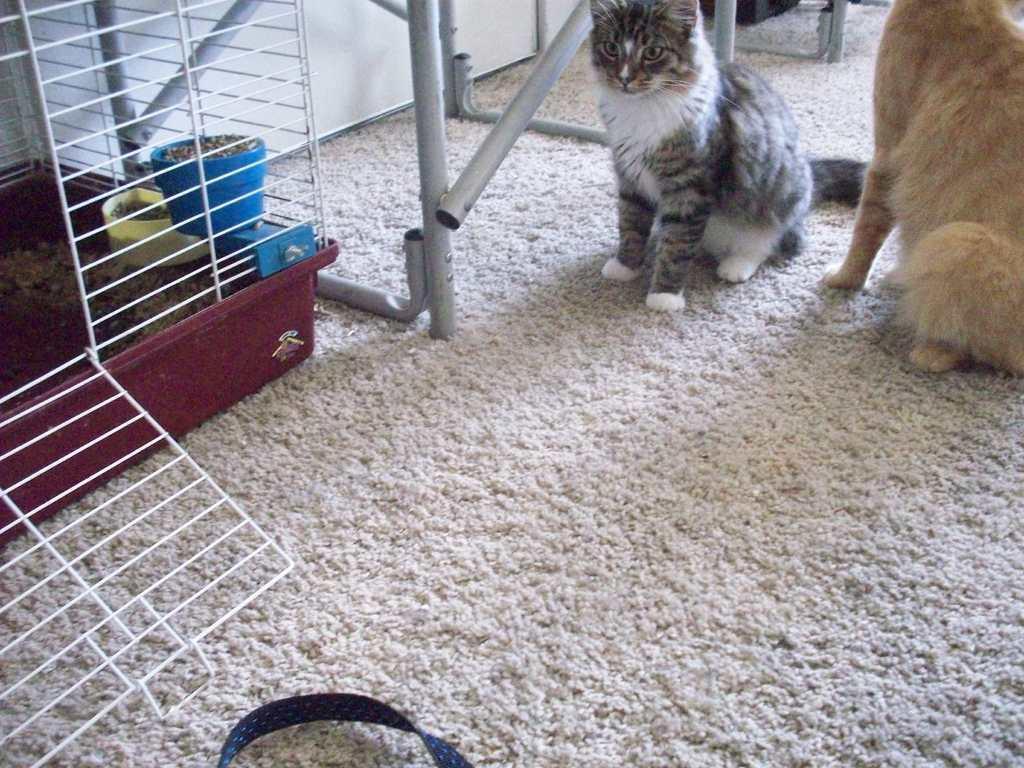How would you summarize this image in a sentence or two? In this image I can see a cage, boxes, metal rods, cat and an animal is sitting on a floor mat. This image is taken may be in a hall. 